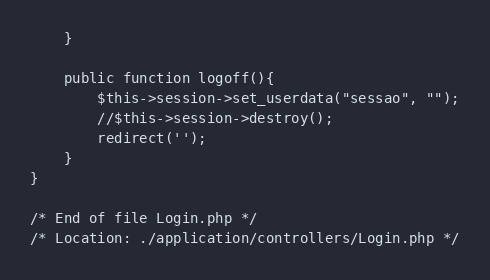<code> <loc_0><loc_0><loc_500><loc_500><_PHP_>	}

	public function logoff(){
 		$this->session->set_userdata("sessao", "");
 		//$this->session->destroy();
 		redirect('');
 	}
}

/* End of file Login.php */
/* Location: ./application/controllers/Login.php */</code> 